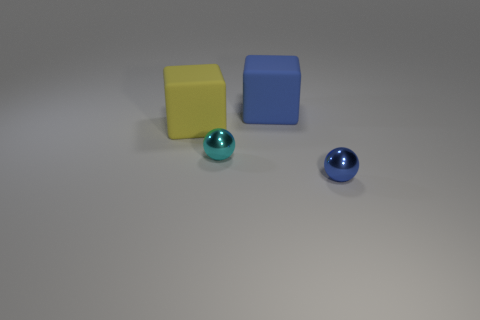Subtract all cyan balls. Subtract all brown blocks. How many balls are left? 1 Add 1 big blue objects. How many objects exist? 5 Add 3 rubber cubes. How many rubber cubes exist? 5 Subtract 0 green balls. How many objects are left? 4 Subtract all large green metal spheres. Subtract all big objects. How many objects are left? 2 Add 4 tiny cyan shiny objects. How many tiny cyan shiny objects are left? 5 